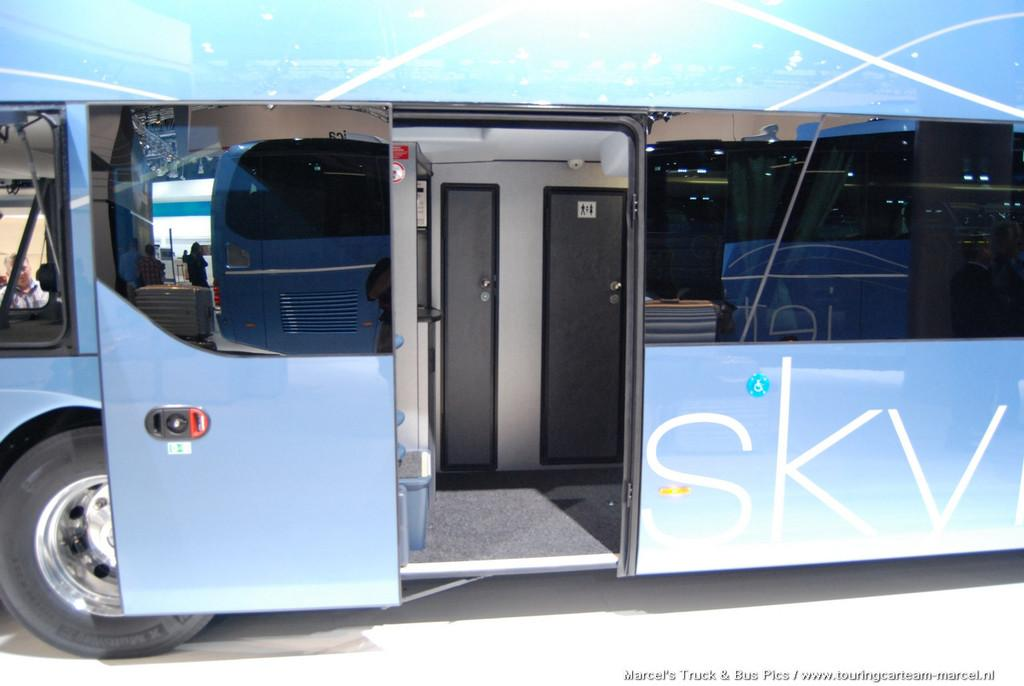What is the main subject of the image? The main subject of the image is a bus. What color is the bus? The bus is colored blue. Can you see any seashore or mask in the image? No, there is no seashore or mask present in the image; it only features a blue bus. 